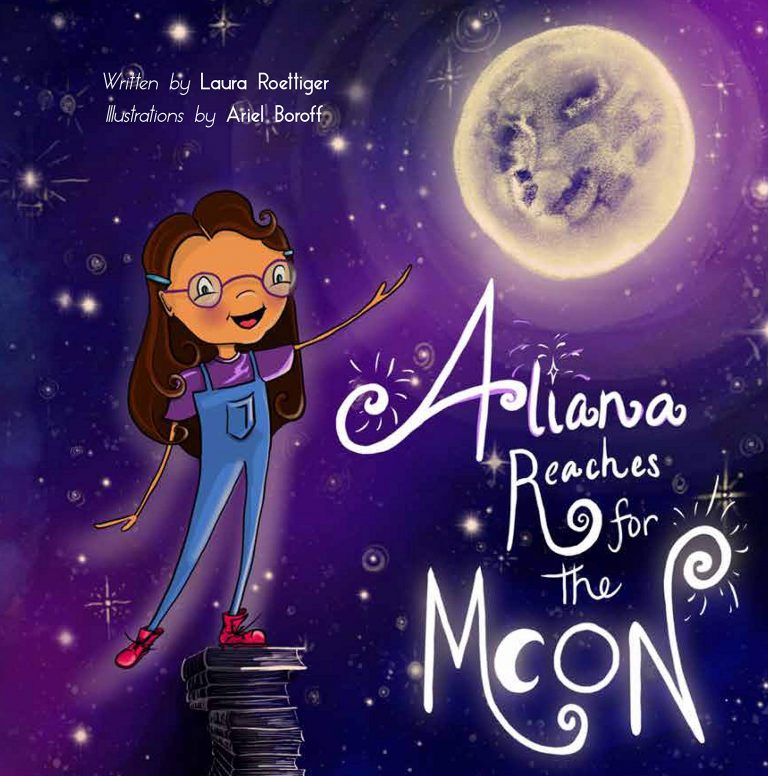How might this story inspire young readers in their everyday lives? This story can inspire young readers by teaching them that education and imagination are powerful tools for achieving their dreams. Aliana's use of books to reach the moon showcases how learning builds a foundation for success. It encourages children to value their education and maintain a sense of wonder about the world. The vivid illustrations and engaging narrative emphasize perseverance and curiosity, showing that with determination and a love for learning, even the highest aspirations can become attainable. Such messages are vital in fostering a growth mindset and a lifelong love of learning in young readers.  What if the books she is standing on start to wobble? How would this add to the story's narrative? If the books Aliana stands on begin to wobble, it would introduce an element of tension and depict the challenges and uncertainties inherent in any ambitious journey. This could symbolize the obstacles and difficulties one might encounter while pursuing dreams. Overcoming this moment of instability would show resilience, problem-solving, and adaptability. It would provide a powerful lesson that even when things get shaky, perseverance and confidence in one's foundation of knowledge can help restore balance. This challenge would add depth to the narrative, illustrating that the path to achieving dreams is as important as the dreams themselves. 